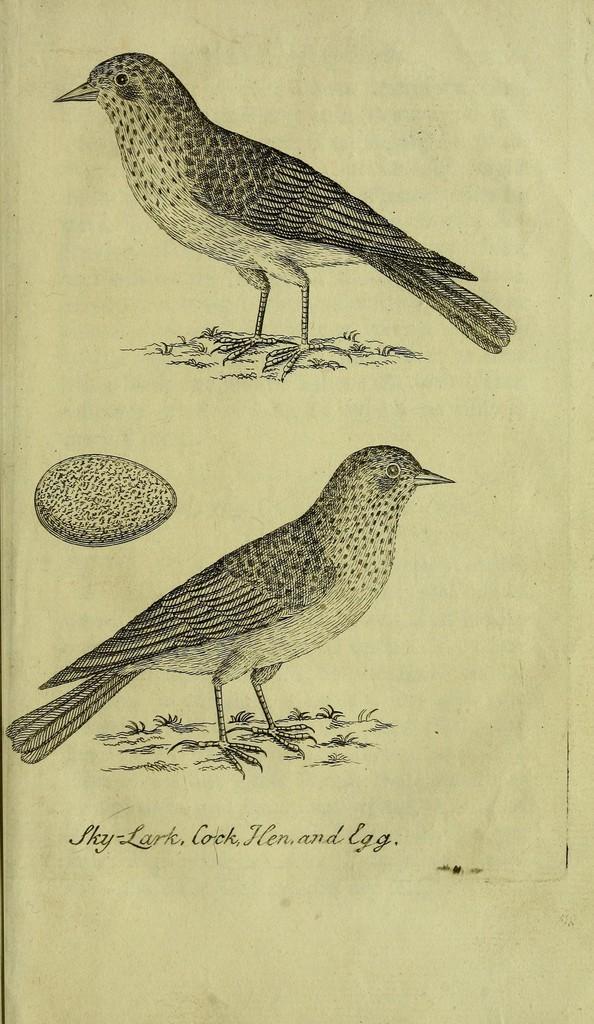Please provide a concise description of this image. In this image we can see depictions of birds and egg on the paper. There is some text. 